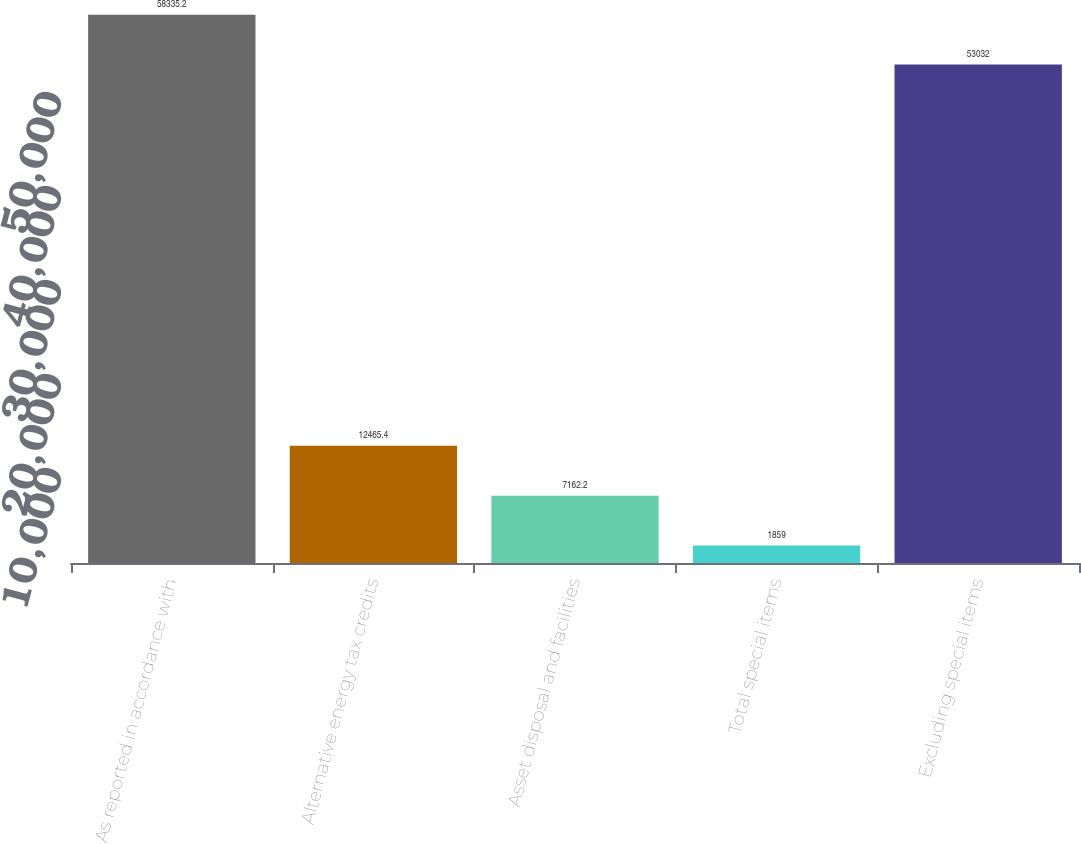Convert chart to OTSL. <chart><loc_0><loc_0><loc_500><loc_500><bar_chart><fcel>As reported in accordance with<fcel>Alternative energy tax credits<fcel>Asset disposal and facilities<fcel>Total special items<fcel>Excluding special items<nl><fcel>58335.2<fcel>12465.4<fcel>7162.2<fcel>1859<fcel>53032<nl></chart> 